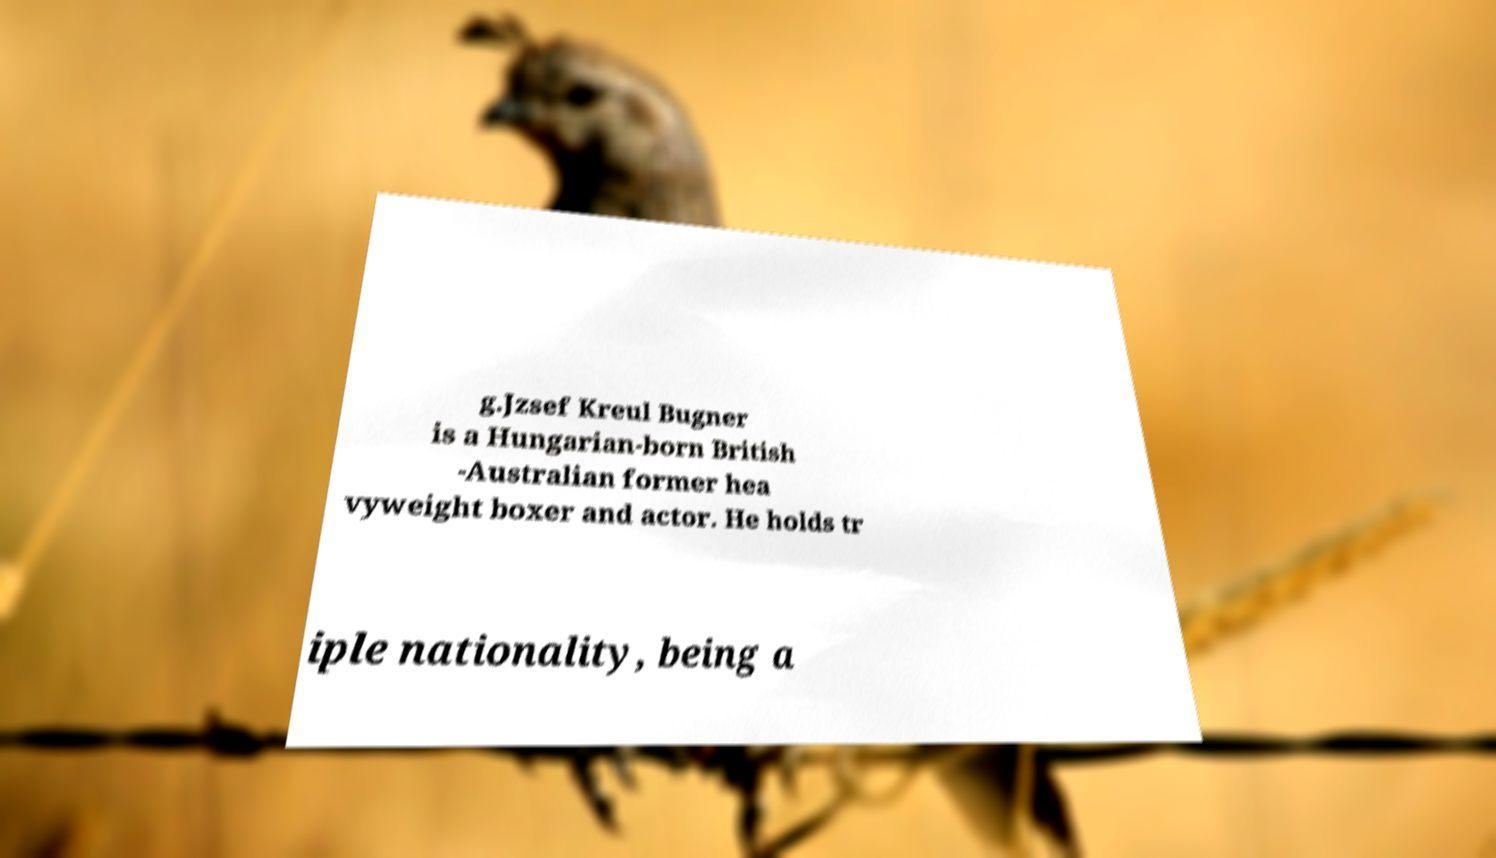I need the written content from this picture converted into text. Can you do that? g.Jzsef Kreul Bugner is a Hungarian-born British -Australian former hea vyweight boxer and actor. He holds tr iple nationality, being a 